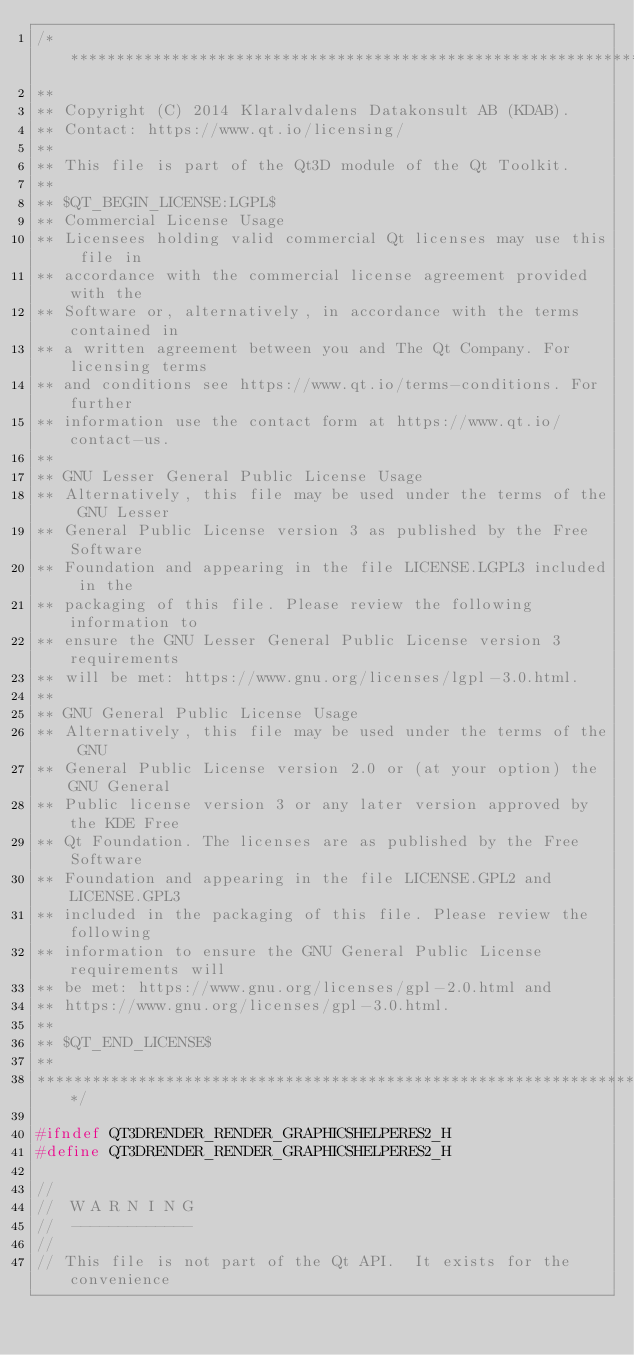<code> <loc_0><loc_0><loc_500><loc_500><_C_>/****************************************************************************
**
** Copyright (C) 2014 Klaralvdalens Datakonsult AB (KDAB).
** Contact: https://www.qt.io/licensing/
**
** This file is part of the Qt3D module of the Qt Toolkit.
**
** $QT_BEGIN_LICENSE:LGPL$
** Commercial License Usage
** Licensees holding valid commercial Qt licenses may use this file in
** accordance with the commercial license agreement provided with the
** Software or, alternatively, in accordance with the terms contained in
** a written agreement between you and The Qt Company. For licensing terms
** and conditions see https://www.qt.io/terms-conditions. For further
** information use the contact form at https://www.qt.io/contact-us.
**
** GNU Lesser General Public License Usage
** Alternatively, this file may be used under the terms of the GNU Lesser
** General Public License version 3 as published by the Free Software
** Foundation and appearing in the file LICENSE.LGPL3 included in the
** packaging of this file. Please review the following information to
** ensure the GNU Lesser General Public License version 3 requirements
** will be met: https://www.gnu.org/licenses/lgpl-3.0.html.
**
** GNU General Public License Usage
** Alternatively, this file may be used under the terms of the GNU
** General Public License version 2.0 or (at your option) the GNU General
** Public license version 3 or any later version approved by the KDE Free
** Qt Foundation. The licenses are as published by the Free Software
** Foundation and appearing in the file LICENSE.GPL2 and LICENSE.GPL3
** included in the packaging of this file. Please review the following
** information to ensure the GNU General Public License requirements will
** be met: https://www.gnu.org/licenses/gpl-2.0.html and
** https://www.gnu.org/licenses/gpl-3.0.html.
**
** $QT_END_LICENSE$
**
****************************************************************************/

#ifndef QT3DRENDER_RENDER_GRAPHICSHELPERES2_H
#define QT3DRENDER_RENDER_GRAPHICSHELPERES2_H

//
//  W A R N I N G
//  -------------
//
// This file is not part of the Qt API.  It exists for the convenience</code> 